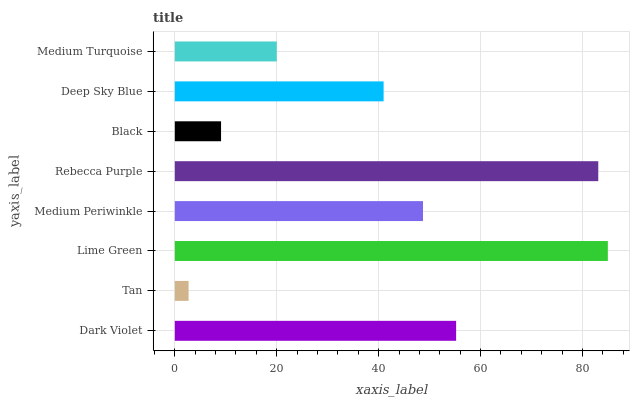Is Tan the minimum?
Answer yes or no. Yes. Is Lime Green the maximum?
Answer yes or no. Yes. Is Lime Green the minimum?
Answer yes or no. No. Is Tan the maximum?
Answer yes or no. No. Is Lime Green greater than Tan?
Answer yes or no. Yes. Is Tan less than Lime Green?
Answer yes or no. Yes. Is Tan greater than Lime Green?
Answer yes or no. No. Is Lime Green less than Tan?
Answer yes or no. No. Is Medium Periwinkle the high median?
Answer yes or no. Yes. Is Deep Sky Blue the low median?
Answer yes or no. Yes. Is Lime Green the high median?
Answer yes or no. No. Is Black the low median?
Answer yes or no. No. 